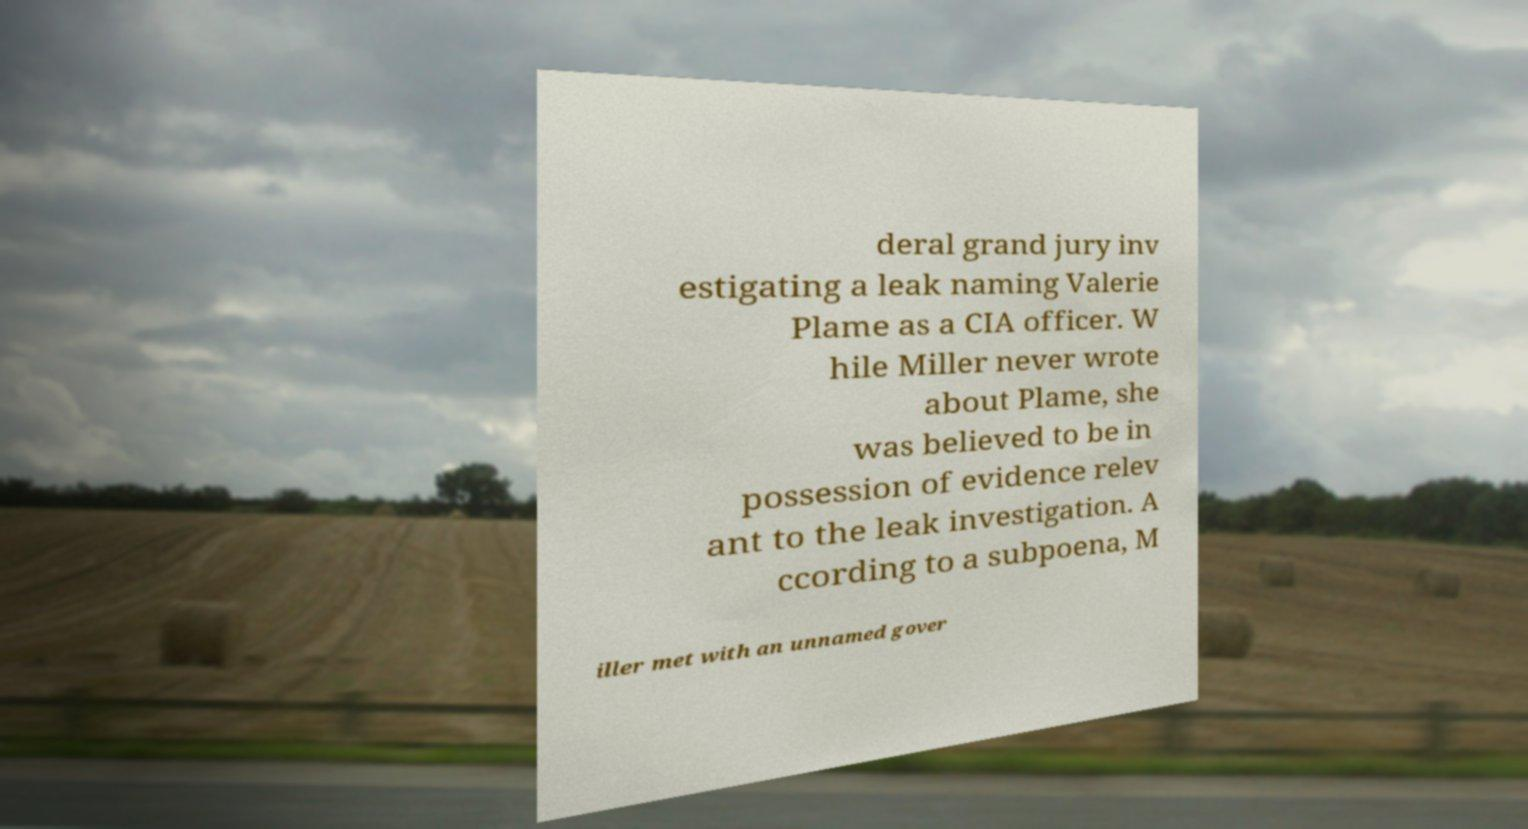Please read and relay the text visible in this image. What does it say? deral grand jury inv estigating a leak naming Valerie Plame as a CIA officer. W hile Miller never wrote about Plame, she was believed to be in possession of evidence relev ant to the leak investigation. A ccording to a subpoena, M iller met with an unnamed gover 